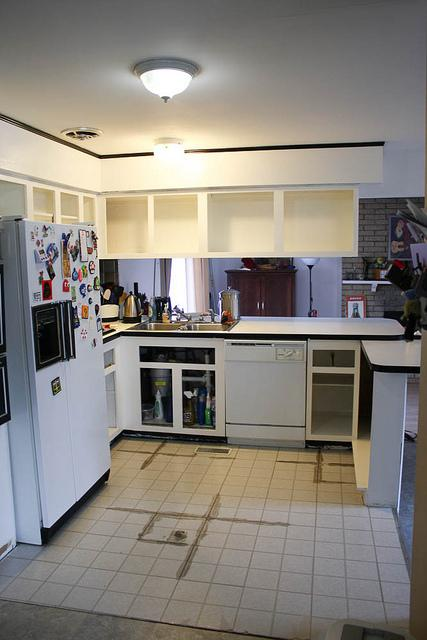What room is beyond the countertops?

Choices:
A) living room
B) office
C) bathroom
D) bedroom living room 